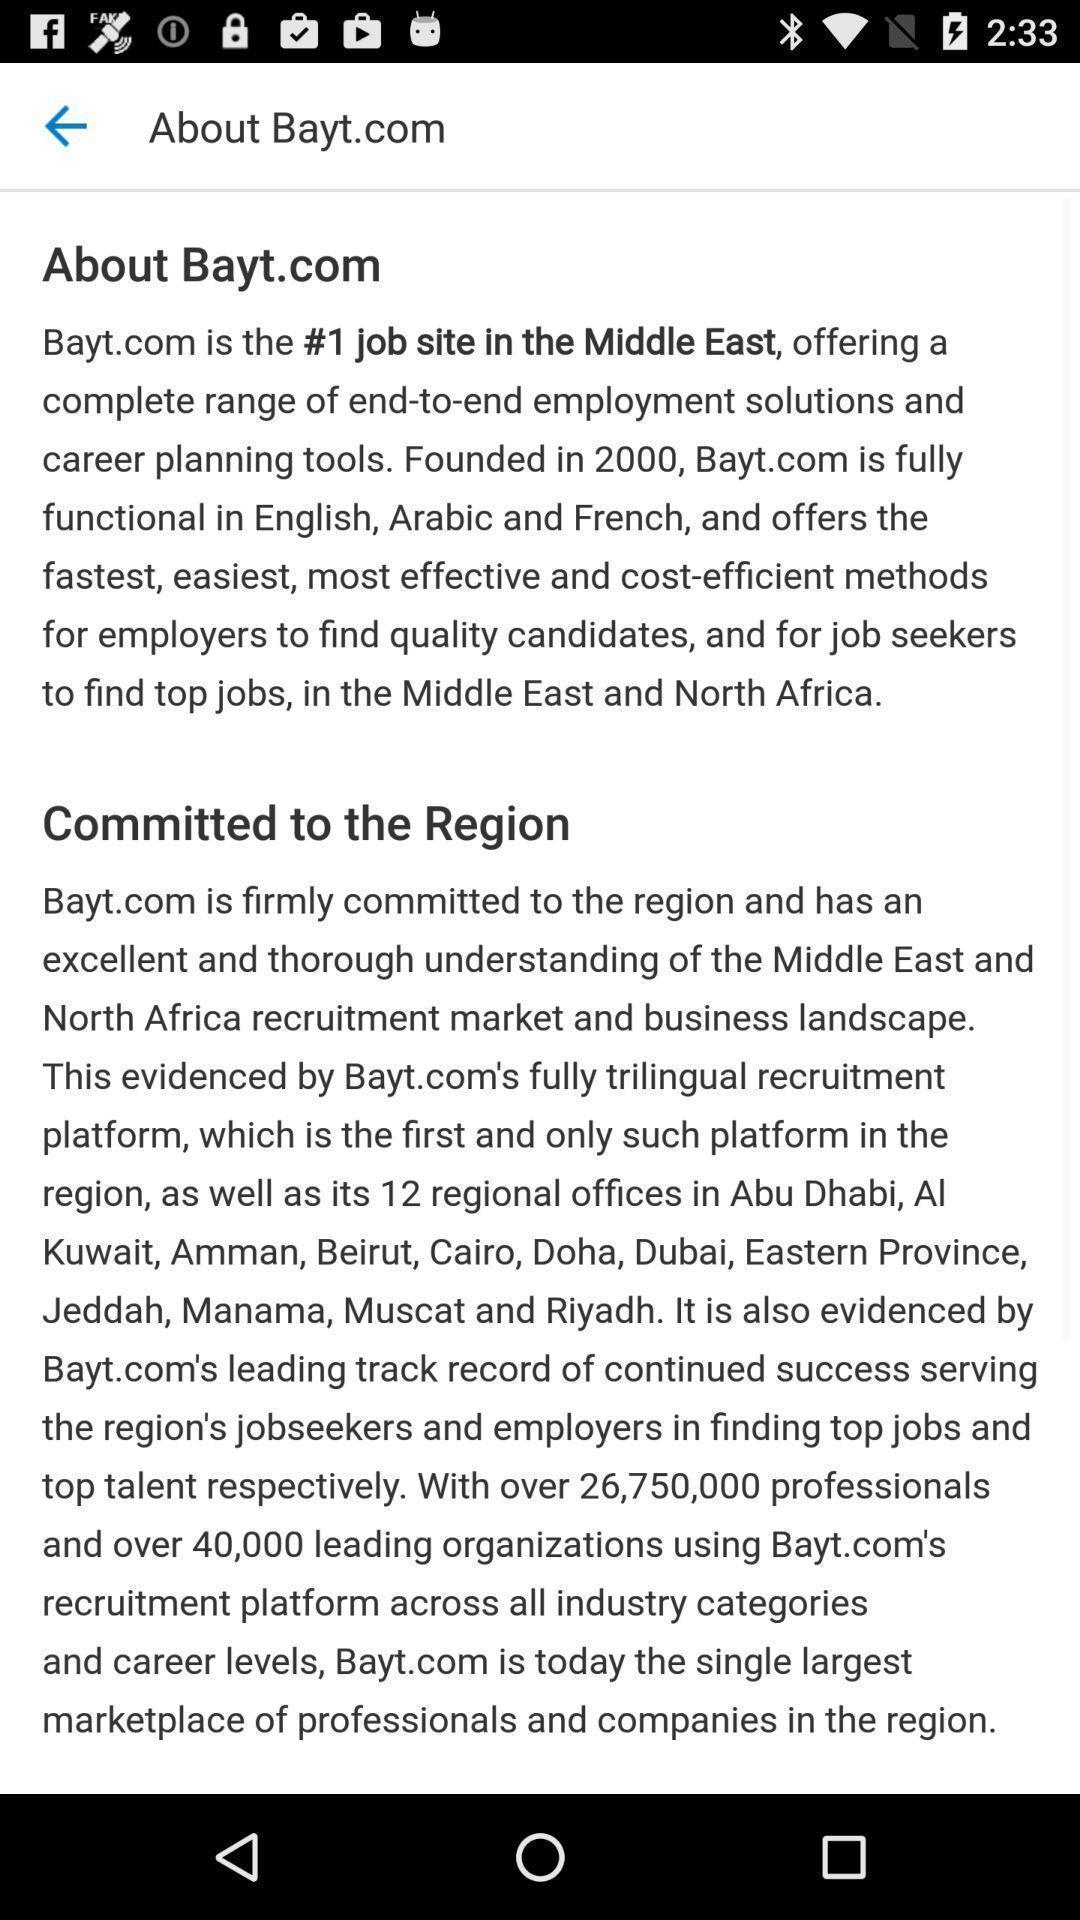Explain the elements present in this screenshot. Text information. 